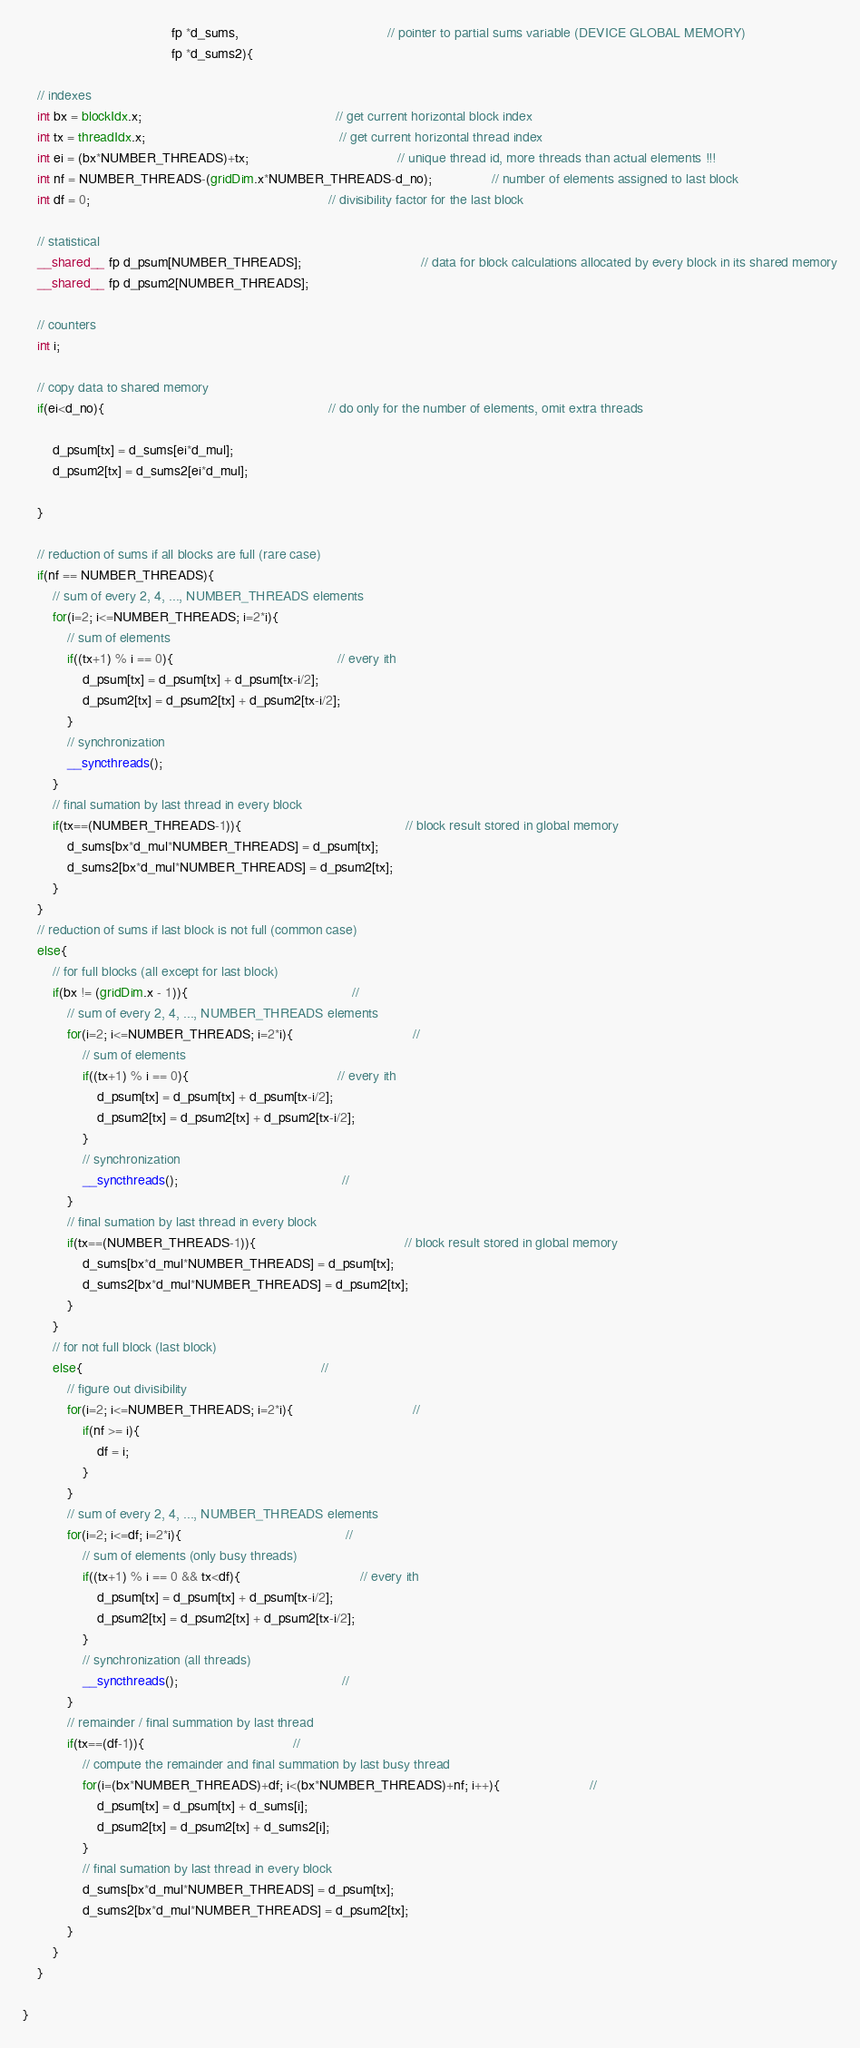Convert code to text. <code><loc_0><loc_0><loc_500><loc_500><_Cuda_>										fp *d_sums,										// pointer to partial sums variable (DEVICE GLOBAL MEMORY)
										fp *d_sums2){

	// indexes
    int bx = blockIdx.x;													// get current horizontal block index
	int tx = threadIdx.x;													// get current horizontal thread index
	int ei = (bx*NUMBER_THREADS)+tx;										// unique thread id, more threads than actual elements !!!
	int nf = NUMBER_THREADS-(gridDim.x*NUMBER_THREADS-d_no);				// number of elements assigned to last block
	int df = 0;																// divisibility factor for the last block

	// statistical
	__shared__ fp d_psum[NUMBER_THREADS];								// data for block calculations allocated by every block in its shared memory
	__shared__ fp d_psum2[NUMBER_THREADS];

	// counters
	int i;

	// copy data to shared memory
	if(ei<d_no){															// do only for the number of elements, omit extra threads

		d_psum[tx] = d_sums[ei*d_mul];
		d_psum2[tx] = d_sums2[ei*d_mul];

	}

	// reduction of sums if all blocks are full (rare case)	
	if(nf == NUMBER_THREADS){
		// sum of every 2, 4, ..., NUMBER_THREADS elements
		for(i=2; i<=NUMBER_THREADS; i=2*i){
			// sum of elements
			if((tx+1) % i == 0){											// every ith
				d_psum[tx] = d_psum[tx] + d_psum[tx-i/2];
				d_psum2[tx] = d_psum2[tx] + d_psum2[tx-i/2];
			}
			// synchronization
			__syncthreads();
		}
		// final sumation by last thread in every block
		if(tx==(NUMBER_THREADS-1)){											// block result stored in global memory
			d_sums[bx*d_mul*NUMBER_THREADS] = d_psum[tx];
			d_sums2[bx*d_mul*NUMBER_THREADS] = d_psum2[tx];
		}
	}
	// reduction of sums if last block is not full (common case)
	else{ 
		// for full blocks (all except for last block)
		if(bx != (gridDim.x - 1)){											//
			// sum of every 2, 4, ..., NUMBER_THREADS elements
			for(i=2; i<=NUMBER_THREADS; i=2*i){								//
				// sum of elements
				if((tx+1) % i == 0){										// every ith
					d_psum[tx] = d_psum[tx] + d_psum[tx-i/2];
					d_psum2[tx] = d_psum2[tx] + d_psum2[tx-i/2];
				}
				// synchronization
				__syncthreads();											//
			}
			// final sumation by last thread in every block
			if(tx==(NUMBER_THREADS-1)){										// block result stored in global memory
				d_sums[bx*d_mul*NUMBER_THREADS] = d_psum[tx];
				d_sums2[bx*d_mul*NUMBER_THREADS] = d_psum2[tx];
			}
		}
		// for not full block (last block)
		else{																//
			// figure out divisibility
			for(i=2; i<=NUMBER_THREADS; i=2*i){								//
				if(nf >= i){
					df = i;
				}
			}
			// sum of every 2, 4, ..., NUMBER_THREADS elements
			for(i=2; i<=df; i=2*i){											//
				// sum of elements (only busy threads)
				if((tx+1) % i == 0 && tx<df){								// every ith
					d_psum[tx] = d_psum[tx] + d_psum[tx-i/2];
					d_psum2[tx] = d_psum2[tx] + d_psum2[tx-i/2];
				}
				// synchronization (all threads)
				__syncthreads();											//
			}
			// remainder / final summation by last thread
			if(tx==(df-1)){										//
				// compute the remainder and final summation by last busy thread
				for(i=(bx*NUMBER_THREADS)+df; i<(bx*NUMBER_THREADS)+nf; i++){						//
					d_psum[tx] = d_psum[tx] + d_sums[i];
					d_psum2[tx] = d_psum2[tx] + d_sums2[i];
				}
				// final sumation by last thread in every block
				d_sums[bx*d_mul*NUMBER_THREADS] = d_psum[tx];
				d_sums2[bx*d_mul*NUMBER_THREADS] = d_psum2[tx];
			}
		}
	}

}
</code> 